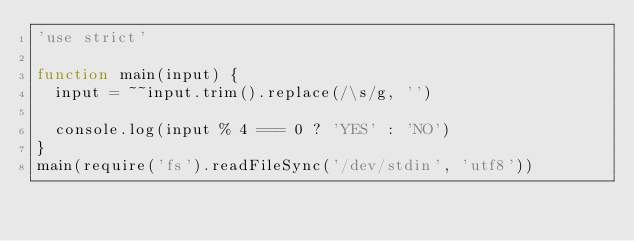Convert code to text. <code><loc_0><loc_0><loc_500><loc_500><_JavaScript_>'use strict'

function main(input) {
  input = ~~input.trim().replace(/\s/g, '')

  console.log(input % 4 === 0 ? 'YES' : 'NO')
}
main(require('fs').readFileSync('/dev/stdin', 'utf8'))
</code> 